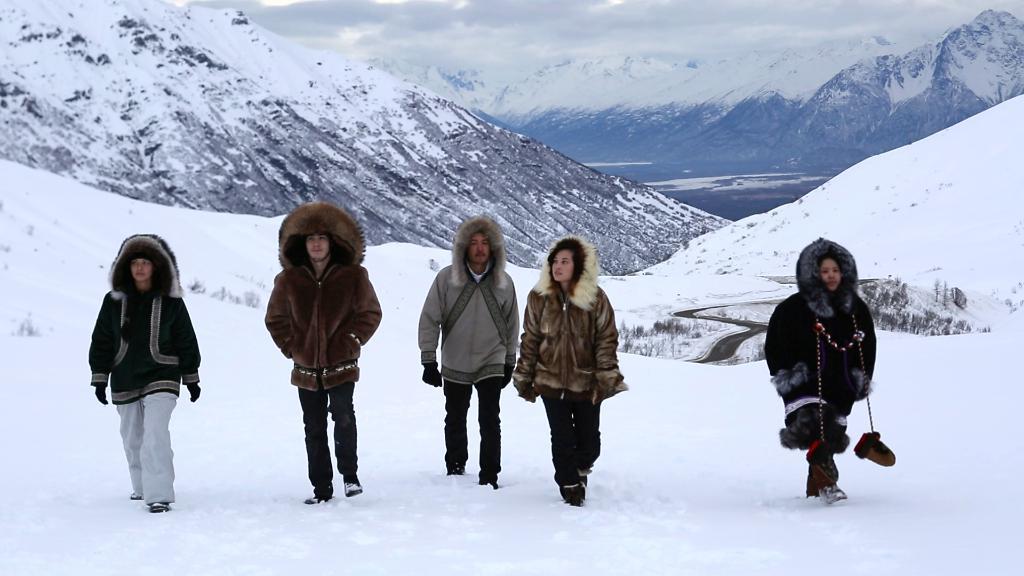How would you summarize this image in a sentence or two? In this image, we can see people are walking on the snow. They are wearing jackets. Background we can see hills and cloudy sky. 